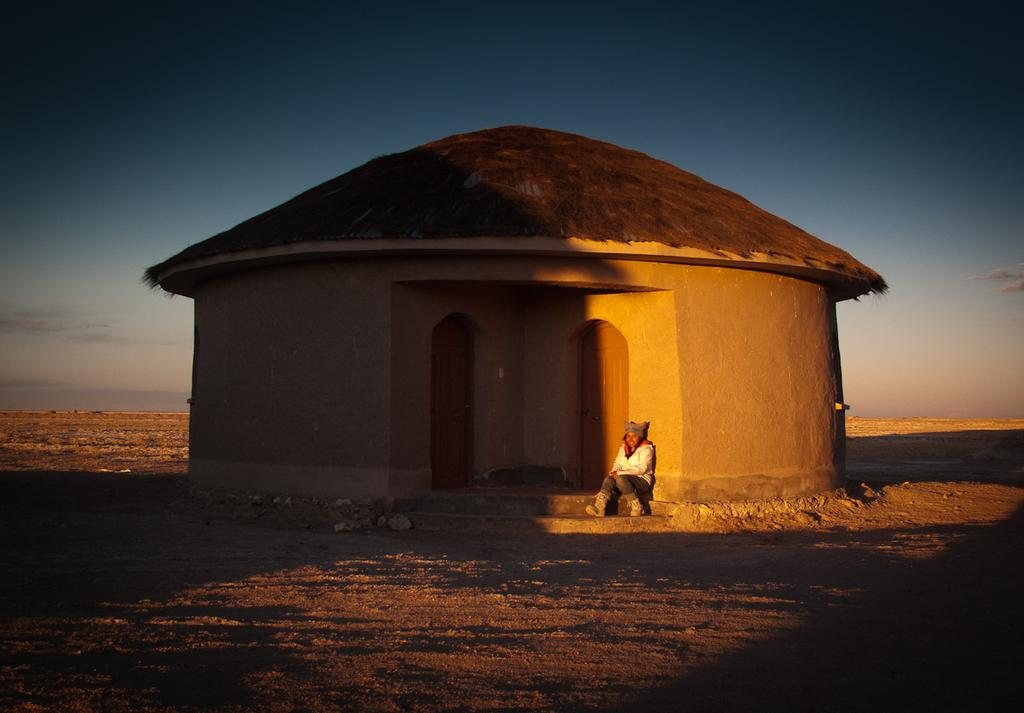What is the main subject of the image? There is a person sitting in the image. Where is the person located in the image? The person is in the middle of the image. What structure can be seen behind the person? There is a small hut behind the person. What is visible at the top of the image? The sky is visible at the top of the image. What type of terrain is present at the bottom of the image? Sand is present at the bottom of the image. What scientific experiment is being conducted in the image? There is no scientific experiment visible in the image; it features a person sitting near a small hut with sand at the bottom and sky at the top. 